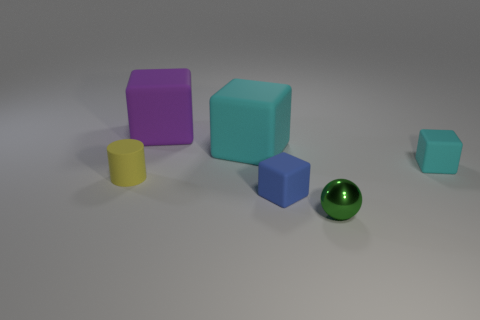Add 4 big purple objects. How many objects exist? 10 Subtract all blue cubes. How many cubes are left? 3 Subtract all blue rubber blocks. How many blocks are left? 3 Subtract 0 purple spheres. How many objects are left? 6 Subtract all cubes. How many objects are left? 2 Subtract 1 cylinders. How many cylinders are left? 0 Subtract all cyan spheres. Subtract all blue blocks. How many spheres are left? 1 Subtract all gray cubes. How many purple balls are left? 0 Subtract all big yellow cylinders. Subtract all rubber blocks. How many objects are left? 2 Add 3 tiny yellow rubber objects. How many tiny yellow rubber objects are left? 4 